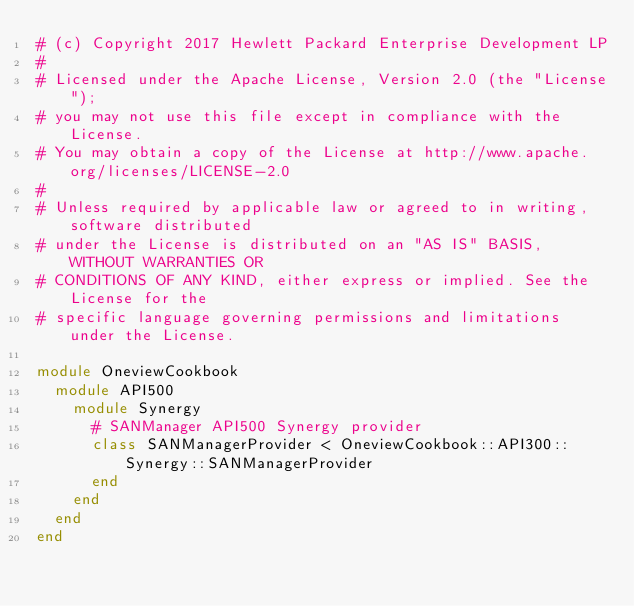<code> <loc_0><loc_0><loc_500><loc_500><_Ruby_># (c) Copyright 2017 Hewlett Packard Enterprise Development LP
#
# Licensed under the Apache License, Version 2.0 (the "License");
# you may not use this file except in compliance with the License.
# You may obtain a copy of the License at http://www.apache.org/licenses/LICENSE-2.0
#
# Unless required by applicable law or agreed to in writing, software distributed
# under the License is distributed on an "AS IS" BASIS, WITHOUT WARRANTIES OR
# CONDITIONS OF ANY KIND, either express or implied. See the License for the
# specific language governing permissions and limitations under the License.

module OneviewCookbook
  module API500
    module Synergy
      # SANManager API500 Synergy provider
      class SANManagerProvider < OneviewCookbook::API300::Synergy::SANManagerProvider
      end
    end
  end
end
</code> 